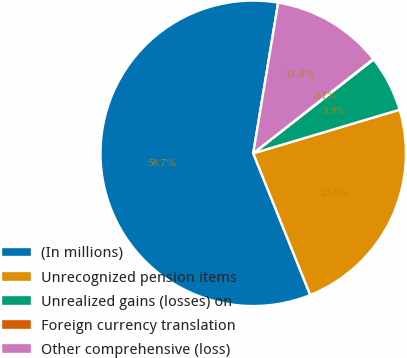Convert chart to OTSL. <chart><loc_0><loc_0><loc_500><loc_500><pie_chart><fcel>(In millions)<fcel>Unrecognized pension items<fcel>Unrealized gains (losses) on<fcel>Foreign currency translation<fcel>Other comprehensive (loss)<nl><fcel>58.7%<fcel>23.52%<fcel>5.93%<fcel>0.06%<fcel>11.79%<nl></chart> 